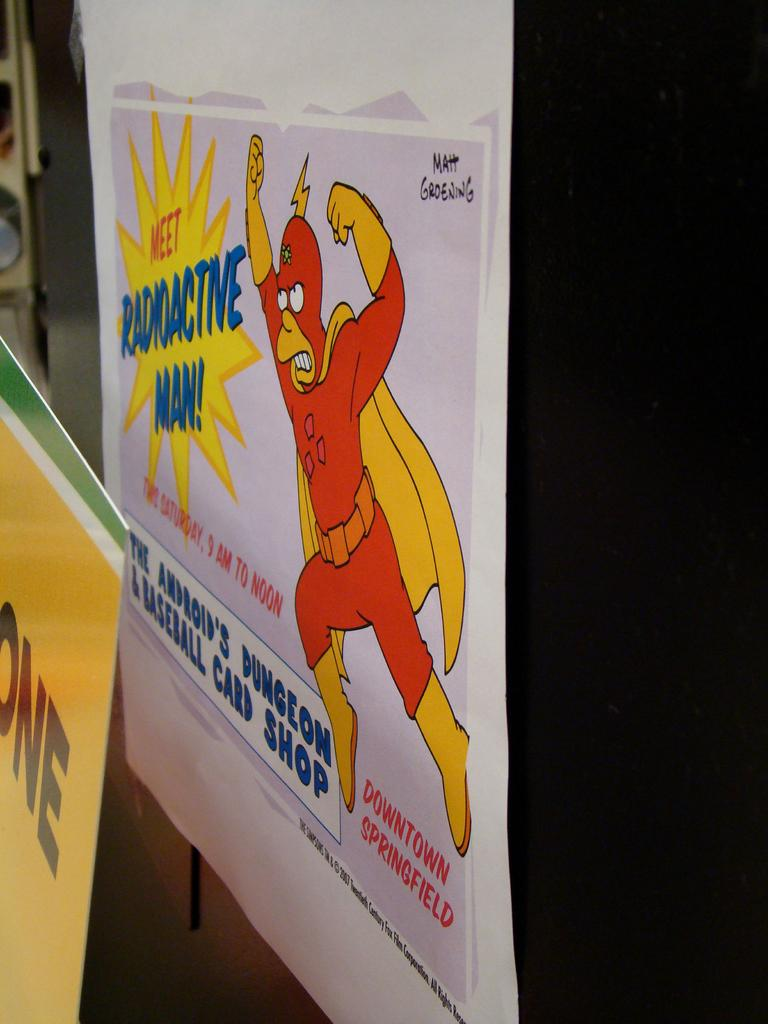<image>
Write a terse but informative summary of the picture. A poster from the Simpsons that says Meet Radioactive Man. 